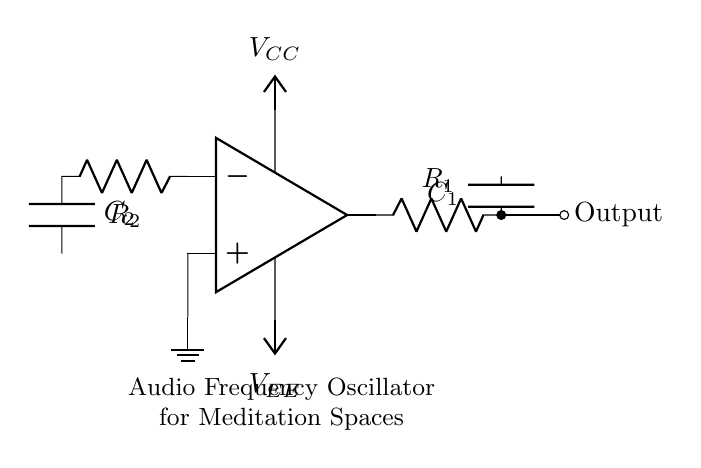What type of oscillator is depicted in this circuit? The circuit is an audio frequency oscillator, as indicated by its purpose in generating sound waves for ambient environments, particularly in meditation spaces.
Answer: audio frequency oscillator How many resistors are in this circuit? There are two resistors in the circuit: R1 and R2, as represented in the circuit diagram.
Answer: 2 What is the function of capacitor C1? Capacitor C1 is part of the feedback network for the oscillator, assisting in determining the frequency of oscillation based on its capacitance and the resistance of R1.
Answer: frequency determination What is the power supply voltage indicated in the circuit? The circuit has a power supply of Vcc, which is typically a positive supply voltage; however, its specific value is not indicated in the diagram.
Answer: Vcc What is the role of the op-amp in this circuit? The op-amp serves as the active component of the oscillator, amplifying the signal and enabling feedback to sustain oscillations.
Answer: signal amplification How does the low-pass filter affect the oscillator's output? The low-pass filter formed by R2 and C2 eliminates high-frequency noise and ensures a smoother output waveform, important for creating ambient sounds.
Answer: smooth waveform Why is the ground connection important in this circuit? The ground connection provides a reference point for voltage levels, ensuring the stability and proper operation of the circuit components, especially the op-amp.
Answer: stability reference 